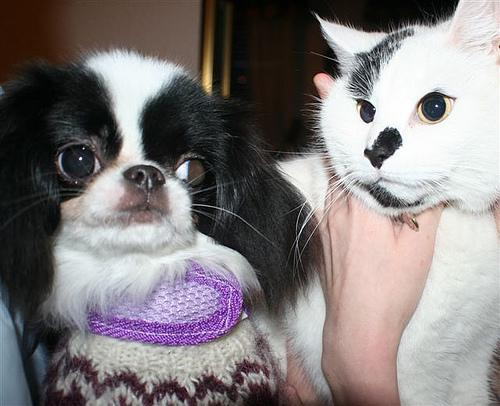How many cats are shown here?

Choices:
A) three
B) two
C) one
D) four one 